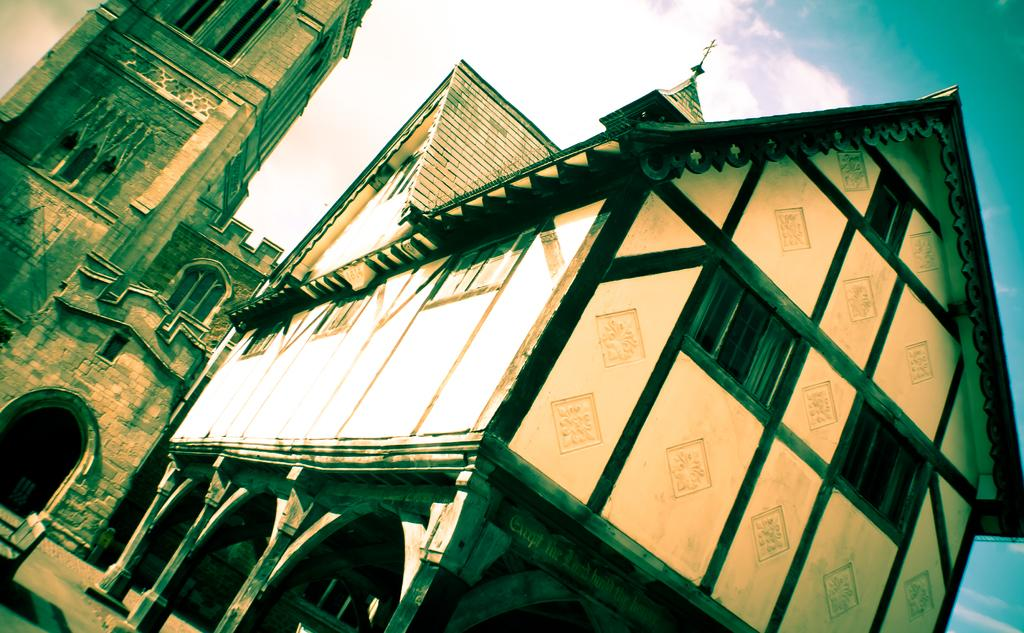What type of structure is located on the right side of the image? There is a building with a roof and windows on the right side of the image. Can you describe the building in the background of the image? There is a building with windows in the background of the image. What can be seen in the sky in the image? There are clouds in the sky, and the sky is blue. What type of beam is holding up the building in the middle of the image? There is no beam present in the image, and the building is not in the middle of the image. Can you describe the spade that is being used to dig in the background of the image? There is no spade present in the image; the background features a building with windows and a blue sky with clouds. 